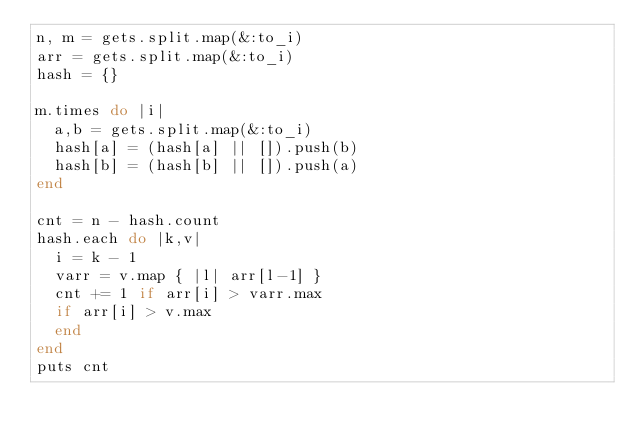<code> <loc_0><loc_0><loc_500><loc_500><_Ruby_>n, m = gets.split.map(&:to_i)
arr = gets.split.map(&:to_i)
hash = {}

m.times do |i|
  a,b = gets.split.map(&:to_i)
  hash[a] = (hash[a] || []).push(b)
  hash[b] = (hash[b] || []).push(a)
end

cnt = n - hash.count
hash.each do |k,v|
  i = k - 1
  varr = v.map { |l| arr[l-1] }
  cnt += 1 if arr[i] > varr.max
  if arr[i] > v.max
  end
end
puts cnt</code> 